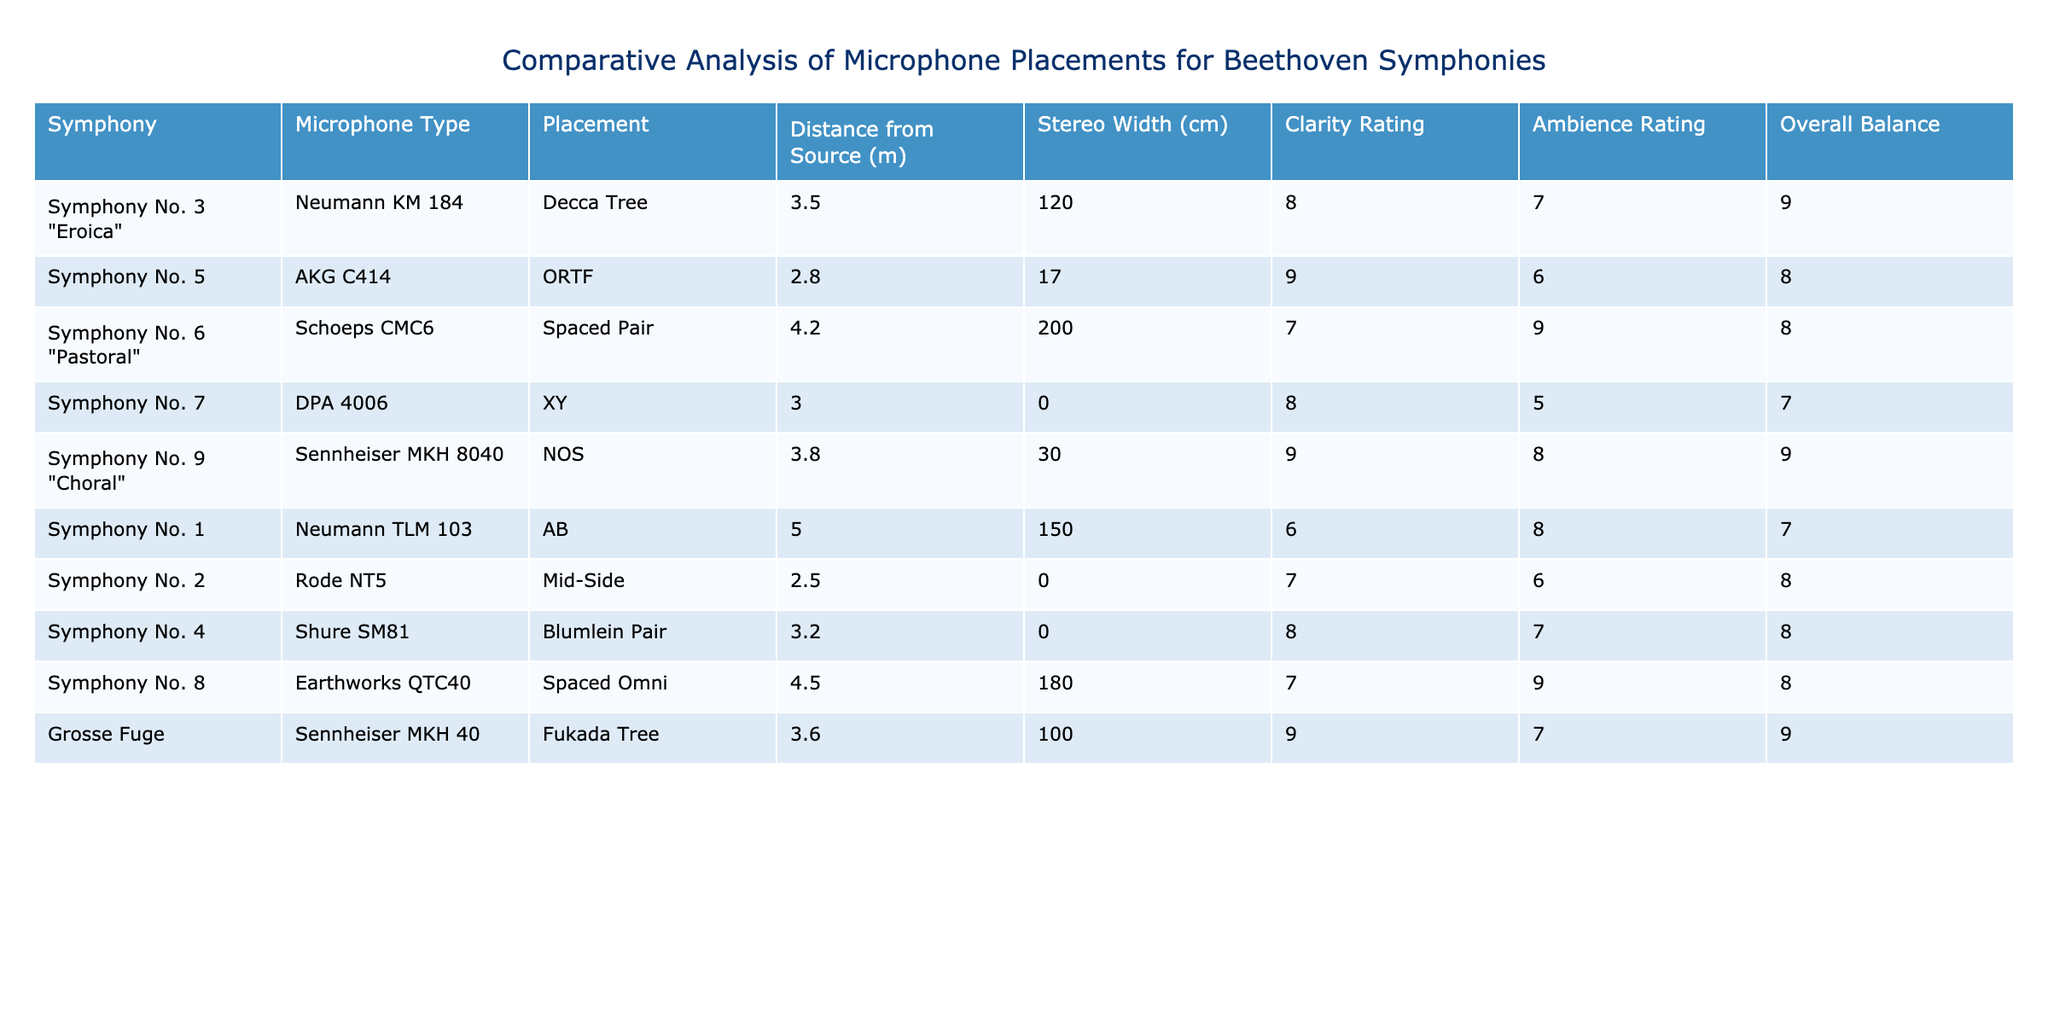What is the microphone type used for Symphony No. 7? By looking at the table, we find the row for Symphony No. 7, which lists the microphone type as DPA 4006.
Answer: DPA 4006 What is the distance from the source for Symphony No. 6 "Pastoral"? In the row for Symphony No. 6 "Pastoral," the distance from the source is listed as 4.2 meters.
Answer: 4.2 m Which symphony has the highest clarity rating? The clarity ratings are 8 for Symphony No. 3 "Eroica," 9 for Symphony No. 5, 7 for Symphony No. 6, 8 for Symphony No. 7, 9 for Symphony No. 9 "Choral," 6 for Symphony No. 1, 7 for Symphony No. 2, 8 for Symphony No. 4, and 7 for Symphony No. 8. The highest is 9, attributed to Symphony No. 5 and Symphony No. 9 "Choral."
Answer: Symphony No. 5 and Symphony No. 9 "Choral" What is the average stereo width of the symphonies recorded? The stereo widths recorded are 120, 17, 200, 0, 30, 150, 0, 0, and 180 cm. Adding these gives 497 cm, and there are 9 symphonies, so the average is 497/9, which is approximately 55.22 cm.
Answer: 55.22 cm Is the ambience rating for Symphony No. 4 higher than that of Symphony No. 2? The ambience rating for Symphony No. 4 is 7, while for Symphony No. 2 it is 6. Since 7 is greater than 6, the statement is true.
Answer: Yes What is the overall balance rating for the symphony with the lowest clarity rating? The only symphony with the lowest clarity rating of 6 is Symphony No. 1. Looking at the table, its overall balance rating is listed as 7.
Answer: 7 What microphone placements yield the highest overall balance ratings? The overall balance ratings are 9 for Symphony No. 3 "Eroica" and Symphony No. 9 "Choral" and 8 for Symphony No. 6 "Pastoral," Symphony No. 6, and Symphony No. 8. Since 9 is the highest, the measurements were made with the Neumann KM 184 and Sennheiser MKH 8040, respectively.
Answer: Neumann KM 184 and Sennheiser MKH 8040 What is the difference in clarity rating between Symphony No. 8 and Symphony No. 3 "Eroica"? Symphony No. 8 has a clarity rating of 7, while Symphony No. 3 "Eroica" has a rating of 8. The difference is 8 - 7 = 1.
Answer: 1 Which microphone placement is used for the Grosse Fuge? The Grosse Fuge's microphone placement listed is the Fukada Tree according to the table.
Answer: Fukada Tree What is the maximum distance from the source for all symphonies? The distances from the source are 3.5, 2.8, 4.2, 3.0, 3.8, 5.0, 2.5, 3.2, and 4.5 meters respectively. The maximum of these values is 5.0 meters, recorded for Symphony No. 1.
Answer: 5.0 m Which symphony has the lowest ambience rating? The ambience ratings are 7, 6, 9, 5, 8, 8, 6, 7, and 9. The lowest rating is 5, which corresponds to Symphony No. 7.
Answer: Symphony No. 7 